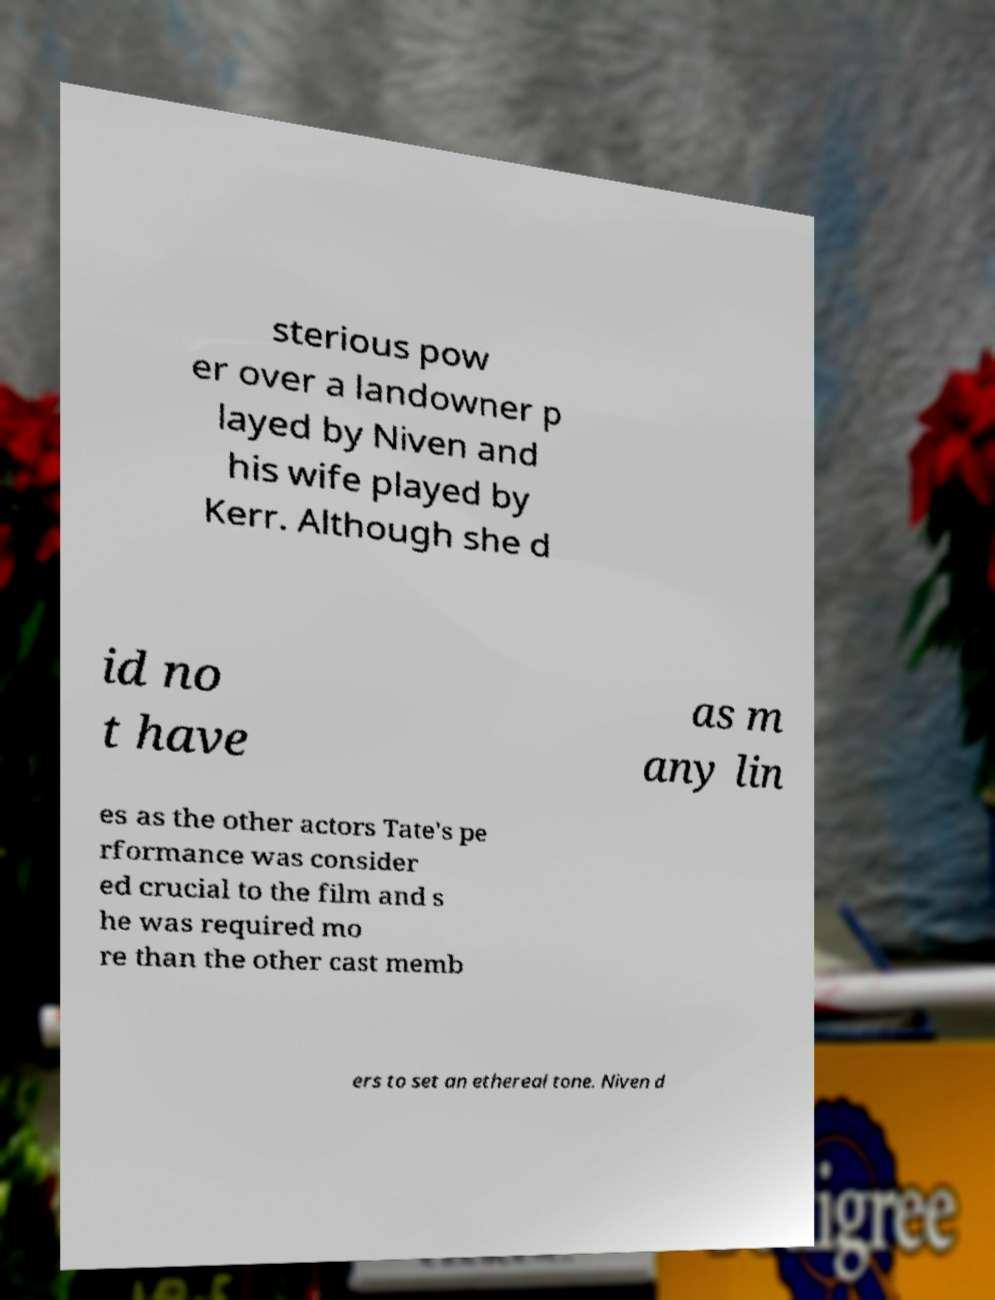For documentation purposes, I need the text within this image transcribed. Could you provide that? sterious pow er over a landowner p layed by Niven and his wife played by Kerr. Although she d id no t have as m any lin es as the other actors Tate's pe rformance was consider ed crucial to the film and s he was required mo re than the other cast memb ers to set an ethereal tone. Niven d 